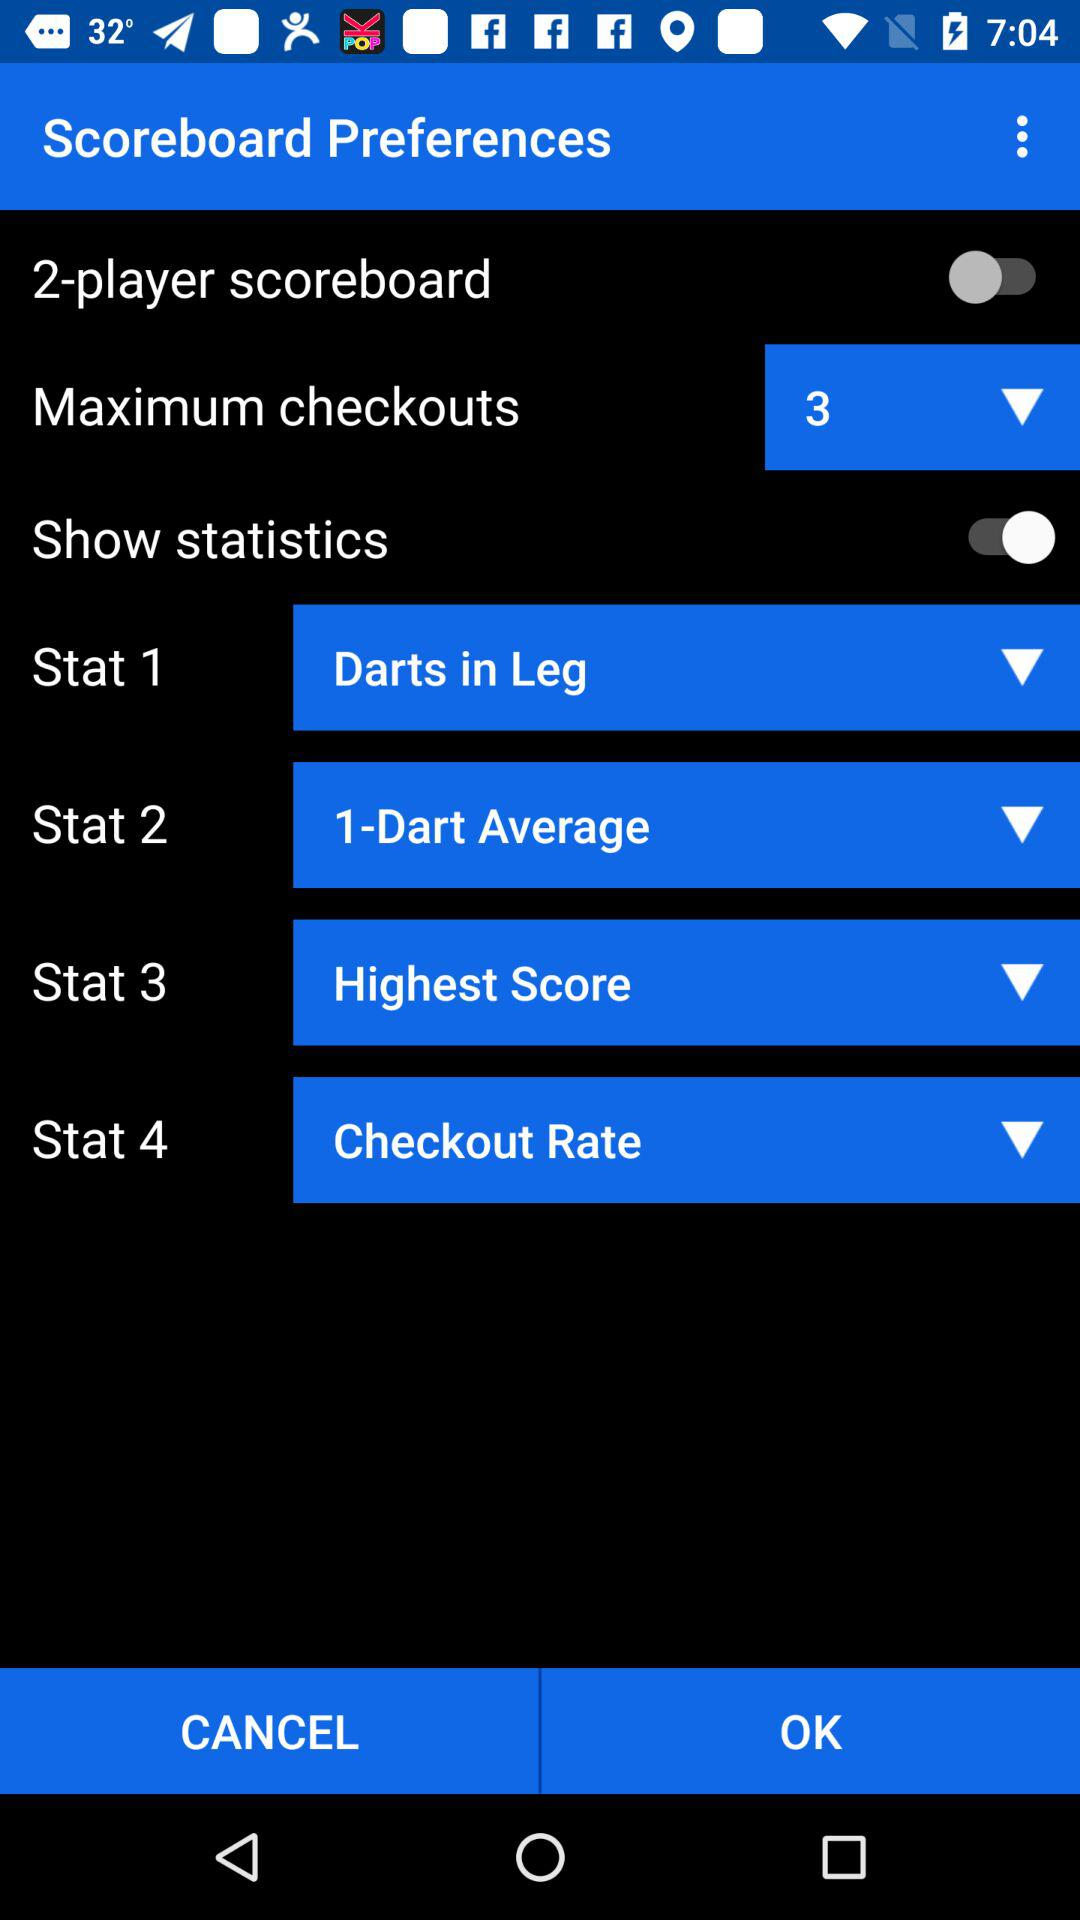What is the count of "Maximum checkouts"? The count of "Maximum checkouts" is 3. 